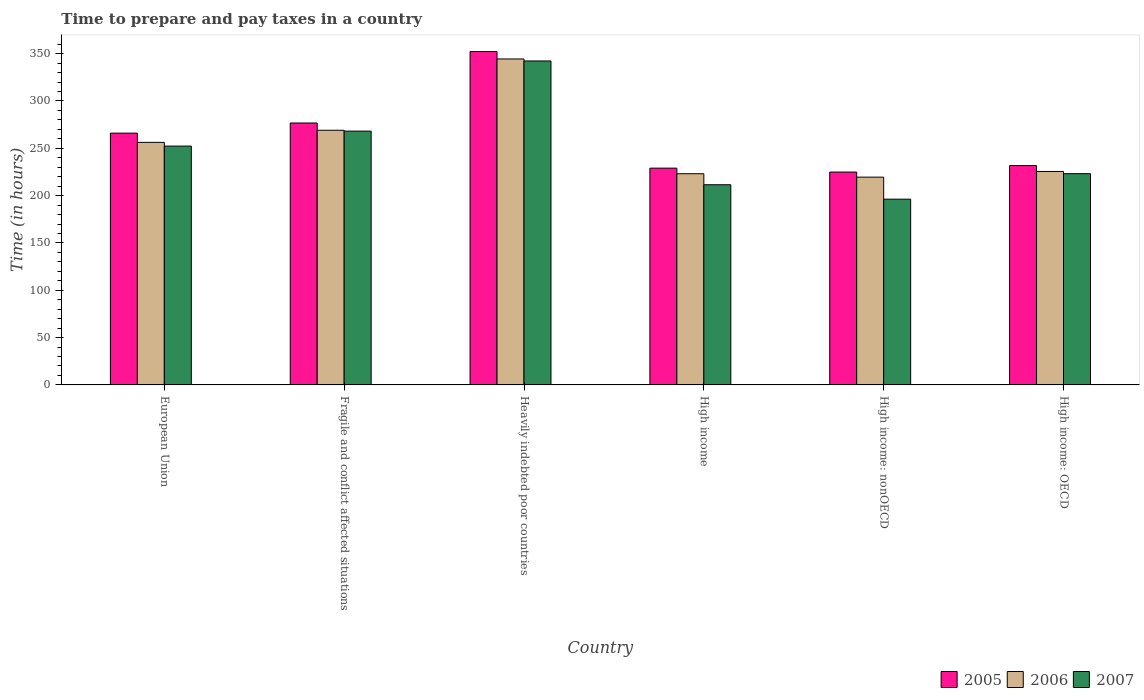How many groups of bars are there?
Offer a terse response. 6. Are the number of bars per tick equal to the number of legend labels?
Your answer should be very brief. Yes. Are the number of bars on each tick of the X-axis equal?
Your response must be concise. Yes. How many bars are there on the 4th tick from the right?
Offer a terse response. 3. What is the label of the 6th group of bars from the left?
Offer a very short reply. High income: OECD. In how many cases, is the number of bars for a given country not equal to the number of legend labels?
Make the answer very short. 0. What is the number of hours required to prepare and pay taxes in 2007 in High income?
Offer a terse response. 211.51. Across all countries, what is the maximum number of hours required to prepare and pay taxes in 2005?
Provide a succinct answer. 352.24. Across all countries, what is the minimum number of hours required to prepare and pay taxes in 2006?
Offer a terse response. 219.55. In which country was the number of hours required to prepare and pay taxes in 2007 maximum?
Your answer should be compact. Heavily indebted poor countries. In which country was the number of hours required to prepare and pay taxes in 2007 minimum?
Provide a succinct answer. High income: nonOECD. What is the total number of hours required to prepare and pay taxes in 2007 in the graph?
Your answer should be very brief. 1493.78. What is the difference between the number of hours required to prepare and pay taxes in 2005 in Heavily indebted poor countries and that in High income: nonOECD?
Ensure brevity in your answer.  127.35. What is the difference between the number of hours required to prepare and pay taxes in 2006 in High income and the number of hours required to prepare and pay taxes in 2005 in High income: OECD?
Provide a succinct answer. -8.62. What is the average number of hours required to prepare and pay taxes in 2007 per country?
Keep it short and to the point. 248.96. What is the difference between the number of hours required to prepare and pay taxes of/in 2007 and number of hours required to prepare and pay taxes of/in 2006 in High income: OECD?
Provide a succinct answer. -2.33. What is the ratio of the number of hours required to prepare and pay taxes in 2005 in High income: OECD to that in High income: nonOECD?
Offer a very short reply. 1.03. Is the number of hours required to prepare and pay taxes in 2006 in European Union less than that in Heavily indebted poor countries?
Keep it short and to the point. Yes. What is the difference between the highest and the second highest number of hours required to prepare and pay taxes in 2007?
Provide a short and direct response. 15.83. What is the difference between the highest and the lowest number of hours required to prepare and pay taxes in 2007?
Offer a terse response. 146.03. In how many countries, is the number of hours required to prepare and pay taxes in 2007 greater than the average number of hours required to prepare and pay taxes in 2007 taken over all countries?
Offer a very short reply. 3. Is the sum of the number of hours required to prepare and pay taxes in 2006 in Heavily indebted poor countries and High income: OECD greater than the maximum number of hours required to prepare and pay taxes in 2007 across all countries?
Your answer should be compact. Yes. What does the 3rd bar from the left in High income represents?
Give a very brief answer. 2007. How many bars are there?
Offer a terse response. 18. How many countries are there in the graph?
Give a very brief answer. 6. Are the values on the major ticks of Y-axis written in scientific E-notation?
Your answer should be very brief. No. Does the graph contain grids?
Provide a succinct answer. No. Where does the legend appear in the graph?
Provide a short and direct response. Bottom right. What is the title of the graph?
Your response must be concise. Time to prepare and pay taxes in a country. What is the label or title of the Y-axis?
Your answer should be very brief. Time (in hours). What is the Time (in hours) of 2005 in European Union?
Your answer should be compact. 266.04. What is the Time (in hours) in 2006 in European Union?
Your answer should be very brief. 256.27. What is the Time (in hours) in 2007 in European Union?
Provide a succinct answer. 252.35. What is the Time (in hours) in 2005 in Fragile and conflict affected situations?
Offer a terse response. 276.75. What is the Time (in hours) in 2006 in Fragile and conflict affected situations?
Your answer should be very brief. 269.07. What is the Time (in hours) of 2007 in Fragile and conflict affected situations?
Make the answer very short. 268.17. What is the Time (in hours) of 2005 in Heavily indebted poor countries?
Ensure brevity in your answer.  352.24. What is the Time (in hours) in 2006 in Heavily indebted poor countries?
Your answer should be very brief. 344.39. What is the Time (in hours) in 2007 in Heavily indebted poor countries?
Offer a very short reply. 342.29. What is the Time (in hours) of 2005 in High income?
Provide a succinct answer. 229.04. What is the Time (in hours) of 2006 in High income?
Offer a very short reply. 223.14. What is the Time (in hours) of 2007 in High income?
Offer a terse response. 211.51. What is the Time (in hours) of 2005 in High income: nonOECD?
Keep it short and to the point. 224.89. What is the Time (in hours) in 2006 in High income: nonOECD?
Keep it short and to the point. 219.55. What is the Time (in hours) of 2007 in High income: nonOECD?
Provide a succinct answer. 196.26. What is the Time (in hours) of 2005 in High income: OECD?
Offer a very short reply. 231.76. What is the Time (in hours) in 2006 in High income: OECD?
Give a very brief answer. 225.53. What is the Time (in hours) of 2007 in High income: OECD?
Make the answer very short. 223.2. Across all countries, what is the maximum Time (in hours) of 2005?
Offer a very short reply. 352.24. Across all countries, what is the maximum Time (in hours) of 2006?
Ensure brevity in your answer.  344.39. Across all countries, what is the maximum Time (in hours) of 2007?
Your answer should be compact. 342.29. Across all countries, what is the minimum Time (in hours) of 2005?
Offer a terse response. 224.89. Across all countries, what is the minimum Time (in hours) of 2006?
Provide a succinct answer. 219.55. Across all countries, what is the minimum Time (in hours) of 2007?
Make the answer very short. 196.26. What is the total Time (in hours) of 2005 in the graph?
Your answer should be very brief. 1580.73. What is the total Time (in hours) in 2006 in the graph?
Offer a very short reply. 1537.96. What is the total Time (in hours) in 2007 in the graph?
Keep it short and to the point. 1493.78. What is the difference between the Time (in hours) of 2005 in European Union and that in Fragile and conflict affected situations?
Make the answer very short. -10.71. What is the difference between the Time (in hours) of 2006 in European Union and that in Fragile and conflict affected situations?
Your answer should be very brief. -12.8. What is the difference between the Time (in hours) of 2007 in European Union and that in Fragile and conflict affected situations?
Your answer should be very brief. -15.83. What is the difference between the Time (in hours) in 2005 in European Union and that in Heavily indebted poor countries?
Offer a very short reply. -86.2. What is the difference between the Time (in hours) of 2006 in European Union and that in Heavily indebted poor countries?
Ensure brevity in your answer.  -88.13. What is the difference between the Time (in hours) of 2007 in European Union and that in Heavily indebted poor countries?
Give a very brief answer. -89.94. What is the difference between the Time (in hours) in 2005 in European Union and that in High income?
Keep it short and to the point. 37. What is the difference between the Time (in hours) in 2006 in European Union and that in High income?
Give a very brief answer. 33.13. What is the difference between the Time (in hours) in 2007 in European Union and that in High income?
Your answer should be compact. 40.84. What is the difference between the Time (in hours) in 2005 in European Union and that in High income: nonOECD?
Provide a succinct answer. 41.15. What is the difference between the Time (in hours) of 2006 in European Union and that in High income: nonOECD?
Make the answer very short. 36.72. What is the difference between the Time (in hours) in 2007 in European Union and that in High income: nonOECD?
Your answer should be very brief. 56.09. What is the difference between the Time (in hours) of 2005 in European Union and that in High income: OECD?
Your answer should be compact. 34.28. What is the difference between the Time (in hours) of 2006 in European Union and that in High income: OECD?
Make the answer very short. 30.74. What is the difference between the Time (in hours) in 2007 in European Union and that in High income: OECD?
Your response must be concise. 29.15. What is the difference between the Time (in hours) of 2005 in Fragile and conflict affected situations and that in Heavily indebted poor countries?
Give a very brief answer. -75.49. What is the difference between the Time (in hours) of 2006 in Fragile and conflict affected situations and that in Heavily indebted poor countries?
Offer a terse response. -75.33. What is the difference between the Time (in hours) in 2007 in Fragile and conflict affected situations and that in Heavily indebted poor countries?
Your response must be concise. -74.12. What is the difference between the Time (in hours) in 2005 in Fragile and conflict affected situations and that in High income?
Ensure brevity in your answer.  47.71. What is the difference between the Time (in hours) of 2006 in Fragile and conflict affected situations and that in High income?
Give a very brief answer. 45.93. What is the difference between the Time (in hours) of 2007 in Fragile and conflict affected situations and that in High income?
Offer a very short reply. 56.66. What is the difference between the Time (in hours) in 2005 in Fragile and conflict affected situations and that in High income: nonOECD?
Your answer should be very brief. 51.86. What is the difference between the Time (in hours) of 2006 in Fragile and conflict affected situations and that in High income: nonOECD?
Keep it short and to the point. 49.52. What is the difference between the Time (in hours) of 2007 in Fragile and conflict affected situations and that in High income: nonOECD?
Offer a very short reply. 71.91. What is the difference between the Time (in hours) of 2005 in Fragile and conflict affected situations and that in High income: OECD?
Your answer should be compact. 44.99. What is the difference between the Time (in hours) in 2006 in Fragile and conflict affected situations and that in High income: OECD?
Your response must be concise. 43.54. What is the difference between the Time (in hours) of 2007 in Fragile and conflict affected situations and that in High income: OECD?
Offer a terse response. 44.97. What is the difference between the Time (in hours) of 2005 in Heavily indebted poor countries and that in High income?
Offer a terse response. 123.2. What is the difference between the Time (in hours) in 2006 in Heavily indebted poor countries and that in High income?
Give a very brief answer. 121.25. What is the difference between the Time (in hours) in 2007 in Heavily indebted poor countries and that in High income?
Provide a short and direct response. 130.78. What is the difference between the Time (in hours) of 2005 in Heavily indebted poor countries and that in High income: nonOECD?
Make the answer very short. 127.35. What is the difference between the Time (in hours) of 2006 in Heavily indebted poor countries and that in High income: nonOECD?
Your answer should be compact. 124.84. What is the difference between the Time (in hours) of 2007 in Heavily indebted poor countries and that in High income: nonOECD?
Your answer should be compact. 146.03. What is the difference between the Time (in hours) in 2005 in Heavily indebted poor countries and that in High income: OECD?
Your answer should be compact. 120.48. What is the difference between the Time (in hours) in 2006 in Heavily indebted poor countries and that in High income: OECD?
Offer a terse response. 118.86. What is the difference between the Time (in hours) in 2007 in Heavily indebted poor countries and that in High income: OECD?
Your answer should be compact. 119.09. What is the difference between the Time (in hours) in 2005 in High income and that in High income: nonOECD?
Offer a terse response. 4.15. What is the difference between the Time (in hours) in 2006 in High income and that in High income: nonOECD?
Provide a succinct answer. 3.59. What is the difference between the Time (in hours) in 2007 in High income and that in High income: nonOECD?
Provide a succinct answer. 15.25. What is the difference between the Time (in hours) of 2005 in High income and that in High income: OECD?
Ensure brevity in your answer.  -2.72. What is the difference between the Time (in hours) in 2006 in High income and that in High income: OECD?
Provide a succinct answer. -2.39. What is the difference between the Time (in hours) in 2007 in High income and that in High income: OECD?
Your answer should be compact. -11.69. What is the difference between the Time (in hours) in 2005 in High income: nonOECD and that in High income: OECD?
Provide a short and direct response. -6.86. What is the difference between the Time (in hours) in 2006 in High income: nonOECD and that in High income: OECD?
Provide a short and direct response. -5.98. What is the difference between the Time (in hours) in 2007 in High income: nonOECD and that in High income: OECD?
Make the answer very short. -26.94. What is the difference between the Time (in hours) of 2005 in European Union and the Time (in hours) of 2006 in Fragile and conflict affected situations?
Give a very brief answer. -3.03. What is the difference between the Time (in hours) of 2005 in European Union and the Time (in hours) of 2007 in Fragile and conflict affected situations?
Make the answer very short. -2.13. What is the difference between the Time (in hours) in 2006 in European Union and the Time (in hours) in 2007 in Fragile and conflict affected situations?
Offer a very short reply. -11.9. What is the difference between the Time (in hours) in 2005 in European Union and the Time (in hours) in 2006 in Heavily indebted poor countries?
Make the answer very short. -78.35. What is the difference between the Time (in hours) in 2005 in European Union and the Time (in hours) in 2007 in Heavily indebted poor countries?
Offer a very short reply. -76.25. What is the difference between the Time (in hours) in 2006 in European Union and the Time (in hours) in 2007 in Heavily indebted poor countries?
Offer a terse response. -86.02. What is the difference between the Time (in hours) in 2005 in European Union and the Time (in hours) in 2006 in High income?
Keep it short and to the point. 42.9. What is the difference between the Time (in hours) of 2005 in European Union and the Time (in hours) of 2007 in High income?
Make the answer very short. 54.53. What is the difference between the Time (in hours) in 2006 in European Union and the Time (in hours) in 2007 in High income?
Your response must be concise. 44.76. What is the difference between the Time (in hours) of 2005 in European Union and the Time (in hours) of 2006 in High income: nonOECD?
Give a very brief answer. 46.49. What is the difference between the Time (in hours) in 2005 in European Union and the Time (in hours) in 2007 in High income: nonOECD?
Your answer should be compact. 69.78. What is the difference between the Time (in hours) in 2006 in European Union and the Time (in hours) in 2007 in High income: nonOECD?
Provide a succinct answer. 60.01. What is the difference between the Time (in hours) in 2005 in European Union and the Time (in hours) in 2006 in High income: OECD?
Provide a succinct answer. 40.51. What is the difference between the Time (in hours) in 2005 in European Union and the Time (in hours) in 2007 in High income: OECD?
Ensure brevity in your answer.  42.84. What is the difference between the Time (in hours) in 2006 in European Union and the Time (in hours) in 2007 in High income: OECD?
Make the answer very short. 33.07. What is the difference between the Time (in hours) in 2005 in Fragile and conflict affected situations and the Time (in hours) in 2006 in Heavily indebted poor countries?
Your answer should be compact. -67.64. What is the difference between the Time (in hours) in 2005 in Fragile and conflict affected situations and the Time (in hours) in 2007 in Heavily indebted poor countries?
Provide a short and direct response. -65.54. What is the difference between the Time (in hours) in 2006 in Fragile and conflict affected situations and the Time (in hours) in 2007 in Heavily indebted poor countries?
Provide a short and direct response. -73.22. What is the difference between the Time (in hours) of 2005 in Fragile and conflict affected situations and the Time (in hours) of 2006 in High income?
Offer a terse response. 53.61. What is the difference between the Time (in hours) in 2005 in Fragile and conflict affected situations and the Time (in hours) in 2007 in High income?
Ensure brevity in your answer.  65.24. What is the difference between the Time (in hours) of 2006 in Fragile and conflict affected situations and the Time (in hours) of 2007 in High income?
Your answer should be compact. 57.56. What is the difference between the Time (in hours) of 2005 in Fragile and conflict affected situations and the Time (in hours) of 2006 in High income: nonOECD?
Give a very brief answer. 57.2. What is the difference between the Time (in hours) in 2005 in Fragile and conflict affected situations and the Time (in hours) in 2007 in High income: nonOECD?
Keep it short and to the point. 80.49. What is the difference between the Time (in hours) of 2006 in Fragile and conflict affected situations and the Time (in hours) of 2007 in High income: nonOECD?
Your answer should be compact. 72.81. What is the difference between the Time (in hours) of 2005 in Fragile and conflict affected situations and the Time (in hours) of 2006 in High income: OECD?
Your answer should be compact. 51.22. What is the difference between the Time (in hours) of 2005 in Fragile and conflict affected situations and the Time (in hours) of 2007 in High income: OECD?
Your response must be concise. 53.55. What is the difference between the Time (in hours) in 2006 in Fragile and conflict affected situations and the Time (in hours) in 2007 in High income: OECD?
Offer a very short reply. 45.87. What is the difference between the Time (in hours) in 2005 in Heavily indebted poor countries and the Time (in hours) in 2006 in High income?
Offer a terse response. 129.1. What is the difference between the Time (in hours) in 2005 in Heavily indebted poor countries and the Time (in hours) in 2007 in High income?
Ensure brevity in your answer.  140.73. What is the difference between the Time (in hours) in 2006 in Heavily indebted poor countries and the Time (in hours) in 2007 in High income?
Your response must be concise. 132.89. What is the difference between the Time (in hours) of 2005 in Heavily indebted poor countries and the Time (in hours) of 2006 in High income: nonOECD?
Offer a very short reply. 132.69. What is the difference between the Time (in hours) of 2005 in Heavily indebted poor countries and the Time (in hours) of 2007 in High income: nonOECD?
Your answer should be very brief. 155.98. What is the difference between the Time (in hours) of 2006 in Heavily indebted poor countries and the Time (in hours) of 2007 in High income: nonOECD?
Give a very brief answer. 148.13. What is the difference between the Time (in hours) of 2005 in Heavily indebted poor countries and the Time (in hours) of 2006 in High income: OECD?
Offer a very short reply. 126.71. What is the difference between the Time (in hours) of 2005 in Heavily indebted poor countries and the Time (in hours) of 2007 in High income: OECD?
Your response must be concise. 129.04. What is the difference between the Time (in hours) in 2006 in Heavily indebted poor countries and the Time (in hours) in 2007 in High income: OECD?
Offer a very short reply. 121.19. What is the difference between the Time (in hours) of 2005 in High income and the Time (in hours) of 2006 in High income: nonOECD?
Keep it short and to the point. 9.49. What is the difference between the Time (in hours) of 2005 in High income and the Time (in hours) of 2007 in High income: nonOECD?
Keep it short and to the point. 32.78. What is the difference between the Time (in hours) in 2006 in High income and the Time (in hours) in 2007 in High income: nonOECD?
Keep it short and to the point. 26.88. What is the difference between the Time (in hours) of 2005 in High income and the Time (in hours) of 2006 in High income: OECD?
Ensure brevity in your answer.  3.51. What is the difference between the Time (in hours) in 2005 in High income and the Time (in hours) in 2007 in High income: OECD?
Your answer should be very brief. 5.84. What is the difference between the Time (in hours) of 2006 in High income and the Time (in hours) of 2007 in High income: OECD?
Keep it short and to the point. -0.06. What is the difference between the Time (in hours) in 2005 in High income: nonOECD and the Time (in hours) in 2006 in High income: OECD?
Your response must be concise. -0.64. What is the difference between the Time (in hours) in 2005 in High income: nonOECD and the Time (in hours) in 2007 in High income: OECD?
Offer a very short reply. 1.69. What is the difference between the Time (in hours) in 2006 in High income: nonOECD and the Time (in hours) in 2007 in High income: OECD?
Offer a very short reply. -3.65. What is the average Time (in hours) of 2005 per country?
Provide a succinct answer. 263.45. What is the average Time (in hours) in 2006 per country?
Your response must be concise. 256.33. What is the average Time (in hours) in 2007 per country?
Your answer should be very brief. 248.96. What is the difference between the Time (in hours) of 2005 and Time (in hours) of 2006 in European Union?
Your answer should be very brief. 9.77. What is the difference between the Time (in hours) in 2005 and Time (in hours) in 2007 in European Union?
Ensure brevity in your answer.  13.69. What is the difference between the Time (in hours) of 2006 and Time (in hours) of 2007 in European Union?
Offer a very short reply. 3.92. What is the difference between the Time (in hours) in 2005 and Time (in hours) in 2006 in Fragile and conflict affected situations?
Your response must be concise. 7.68. What is the difference between the Time (in hours) of 2005 and Time (in hours) of 2007 in Fragile and conflict affected situations?
Offer a very short reply. 8.58. What is the difference between the Time (in hours) in 2006 and Time (in hours) in 2007 in Fragile and conflict affected situations?
Provide a short and direct response. 0.9. What is the difference between the Time (in hours) in 2005 and Time (in hours) in 2006 in Heavily indebted poor countries?
Provide a short and direct response. 7.85. What is the difference between the Time (in hours) of 2005 and Time (in hours) of 2007 in Heavily indebted poor countries?
Ensure brevity in your answer.  9.95. What is the difference between the Time (in hours) of 2006 and Time (in hours) of 2007 in Heavily indebted poor countries?
Your answer should be very brief. 2.11. What is the difference between the Time (in hours) in 2005 and Time (in hours) in 2006 in High income?
Offer a very short reply. 5.9. What is the difference between the Time (in hours) in 2005 and Time (in hours) in 2007 in High income?
Offer a terse response. 17.53. What is the difference between the Time (in hours) of 2006 and Time (in hours) of 2007 in High income?
Make the answer very short. 11.63. What is the difference between the Time (in hours) in 2005 and Time (in hours) in 2006 in High income: nonOECD?
Provide a succinct answer. 5.34. What is the difference between the Time (in hours) in 2005 and Time (in hours) in 2007 in High income: nonOECD?
Your response must be concise. 28.63. What is the difference between the Time (in hours) of 2006 and Time (in hours) of 2007 in High income: nonOECD?
Offer a terse response. 23.29. What is the difference between the Time (in hours) of 2005 and Time (in hours) of 2006 in High income: OECD?
Provide a succinct answer. 6.23. What is the difference between the Time (in hours) of 2005 and Time (in hours) of 2007 in High income: OECD?
Offer a terse response. 8.56. What is the difference between the Time (in hours) in 2006 and Time (in hours) in 2007 in High income: OECD?
Ensure brevity in your answer.  2.33. What is the ratio of the Time (in hours) in 2005 in European Union to that in Fragile and conflict affected situations?
Your answer should be very brief. 0.96. What is the ratio of the Time (in hours) of 2006 in European Union to that in Fragile and conflict affected situations?
Provide a short and direct response. 0.95. What is the ratio of the Time (in hours) in 2007 in European Union to that in Fragile and conflict affected situations?
Provide a succinct answer. 0.94. What is the ratio of the Time (in hours) in 2005 in European Union to that in Heavily indebted poor countries?
Your answer should be compact. 0.76. What is the ratio of the Time (in hours) in 2006 in European Union to that in Heavily indebted poor countries?
Your response must be concise. 0.74. What is the ratio of the Time (in hours) of 2007 in European Union to that in Heavily indebted poor countries?
Your answer should be very brief. 0.74. What is the ratio of the Time (in hours) in 2005 in European Union to that in High income?
Provide a succinct answer. 1.16. What is the ratio of the Time (in hours) in 2006 in European Union to that in High income?
Your answer should be very brief. 1.15. What is the ratio of the Time (in hours) of 2007 in European Union to that in High income?
Offer a terse response. 1.19. What is the ratio of the Time (in hours) in 2005 in European Union to that in High income: nonOECD?
Make the answer very short. 1.18. What is the ratio of the Time (in hours) of 2006 in European Union to that in High income: nonOECD?
Provide a succinct answer. 1.17. What is the ratio of the Time (in hours) in 2007 in European Union to that in High income: nonOECD?
Provide a short and direct response. 1.29. What is the ratio of the Time (in hours) of 2005 in European Union to that in High income: OECD?
Ensure brevity in your answer.  1.15. What is the ratio of the Time (in hours) in 2006 in European Union to that in High income: OECD?
Provide a succinct answer. 1.14. What is the ratio of the Time (in hours) in 2007 in European Union to that in High income: OECD?
Make the answer very short. 1.13. What is the ratio of the Time (in hours) of 2005 in Fragile and conflict affected situations to that in Heavily indebted poor countries?
Make the answer very short. 0.79. What is the ratio of the Time (in hours) in 2006 in Fragile and conflict affected situations to that in Heavily indebted poor countries?
Your answer should be very brief. 0.78. What is the ratio of the Time (in hours) in 2007 in Fragile and conflict affected situations to that in Heavily indebted poor countries?
Provide a short and direct response. 0.78. What is the ratio of the Time (in hours) of 2005 in Fragile and conflict affected situations to that in High income?
Make the answer very short. 1.21. What is the ratio of the Time (in hours) in 2006 in Fragile and conflict affected situations to that in High income?
Provide a short and direct response. 1.21. What is the ratio of the Time (in hours) of 2007 in Fragile and conflict affected situations to that in High income?
Offer a terse response. 1.27. What is the ratio of the Time (in hours) of 2005 in Fragile and conflict affected situations to that in High income: nonOECD?
Offer a terse response. 1.23. What is the ratio of the Time (in hours) of 2006 in Fragile and conflict affected situations to that in High income: nonOECD?
Provide a succinct answer. 1.23. What is the ratio of the Time (in hours) in 2007 in Fragile and conflict affected situations to that in High income: nonOECD?
Keep it short and to the point. 1.37. What is the ratio of the Time (in hours) of 2005 in Fragile and conflict affected situations to that in High income: OECD?
Keep it short and to the point. 1.19. What is the ratio of the Time (in hours) in 2006 in Fragile and conflict affected situations to that in High income: OECD?
Make the answer very short. 1.19. What is the ratio of the Time (in hours) of 2007 in Fragile and conflict affected situations to that in High income: OECD?
Make the answer very short. 1.2. What is the ratio of the Time (in hours) in 2005 in Heavily indebted poor countries to that in High income?
Offer a very short reply. 1.54. What is the ratio of the Time (in hours) of 2006 in Heavily indebted poor countries to that in High income?
Your response must be concise. 1.54. What is the ratio of the Time (in hours) of 2007 in Heavily indebted poor countries to that in High income?
Your answer should be compact. 1.62. What is the ratio of the Time (in hours) of 2005 in Heavily indebted poor countries to that in High income: nonOECD?
Offer a very short reply. 1.57. What is the ratio of the Time (in hours) in 2006 in Heavily indebted poor countries to that in High income: nonOECD?
Offer a very short reply. 1.57. What is the ratio of the Time (in hours) in 2007 in Heavily indebted poor countries to that in High income: nonOECD?
Provide a short and direct response. 1.74. What is the ratio of the Time (in hours) of 2005 in Heavily indebted poor countries to that in High income: OECD?
Provide a short and direct response. 1.52. What is the ratio of the Time (in hours) of 2006 in Heavily indebted poor countries to that in High income: OECD?
Offer a very short reply. 1.53. What is the ratio of the Time (in hours) in 2007 in Heavily indebted poor countries to that in High income: OECD?
Offer a very short reply. 1.53. What is the ratio of the Time (in hours) in 2005 in High income to that in High income: nonOECD?
Provide a succinct answer. 1.02. What is the ratio of the Time (in hours) in 2006 in High income to that in High income: nonOECD?
Provide a short and direct response. 1.02. What is the ratio of the Time (in hours) of 2007 in High income to that in High income: nonOECD?
Provide a short and direct response. 1.08. What is the ratio of the Time (in hours) of 2005 in High income to that in High income: OECD?
Provide a succinct answer. 0.99. What is the ratio of the Time (in hours) of 2007 in High income to that in High income: OECD?
Your answer should be compact. 0.95. What is the ratio of the Time (in hours) in 2005 in High income: nonOECD to that in High income: OECD?
Your answer should be compact. 0.97. What is the ratio of the Time (in hours) of 2006 in High income: nonOECD to that in High income: OECD?
Offer a terse response. 0.97. What is the ratio of the Time (in hours) of 2007 in High income: nonOECD to that in High income: OECD?
Make the answer very short. 0.88. What is the difference between the highest and the second highest Time (in hours) in 2005?
Your answer should be very brief. 75.49. What is the difference between the highest and the second highest Time (in hours) in 2006?
Your answer should be very brief. 75.33. What is the difference between the highest and the second highest Time (in hours) in 2007?
Keep it short and to the point. 74.12. What is the difference between the highest and the lowest Time (in hours) in 2005?
Keep it short and to the point. 127.35. What is the difference between the highest and the lowest Time (in hours) of 2006?
Offer a very short reply. 124.84. What is the difference between the highest and the lowest Time (in hours) in 2007?
Provide a succinct answer. 146.03. 